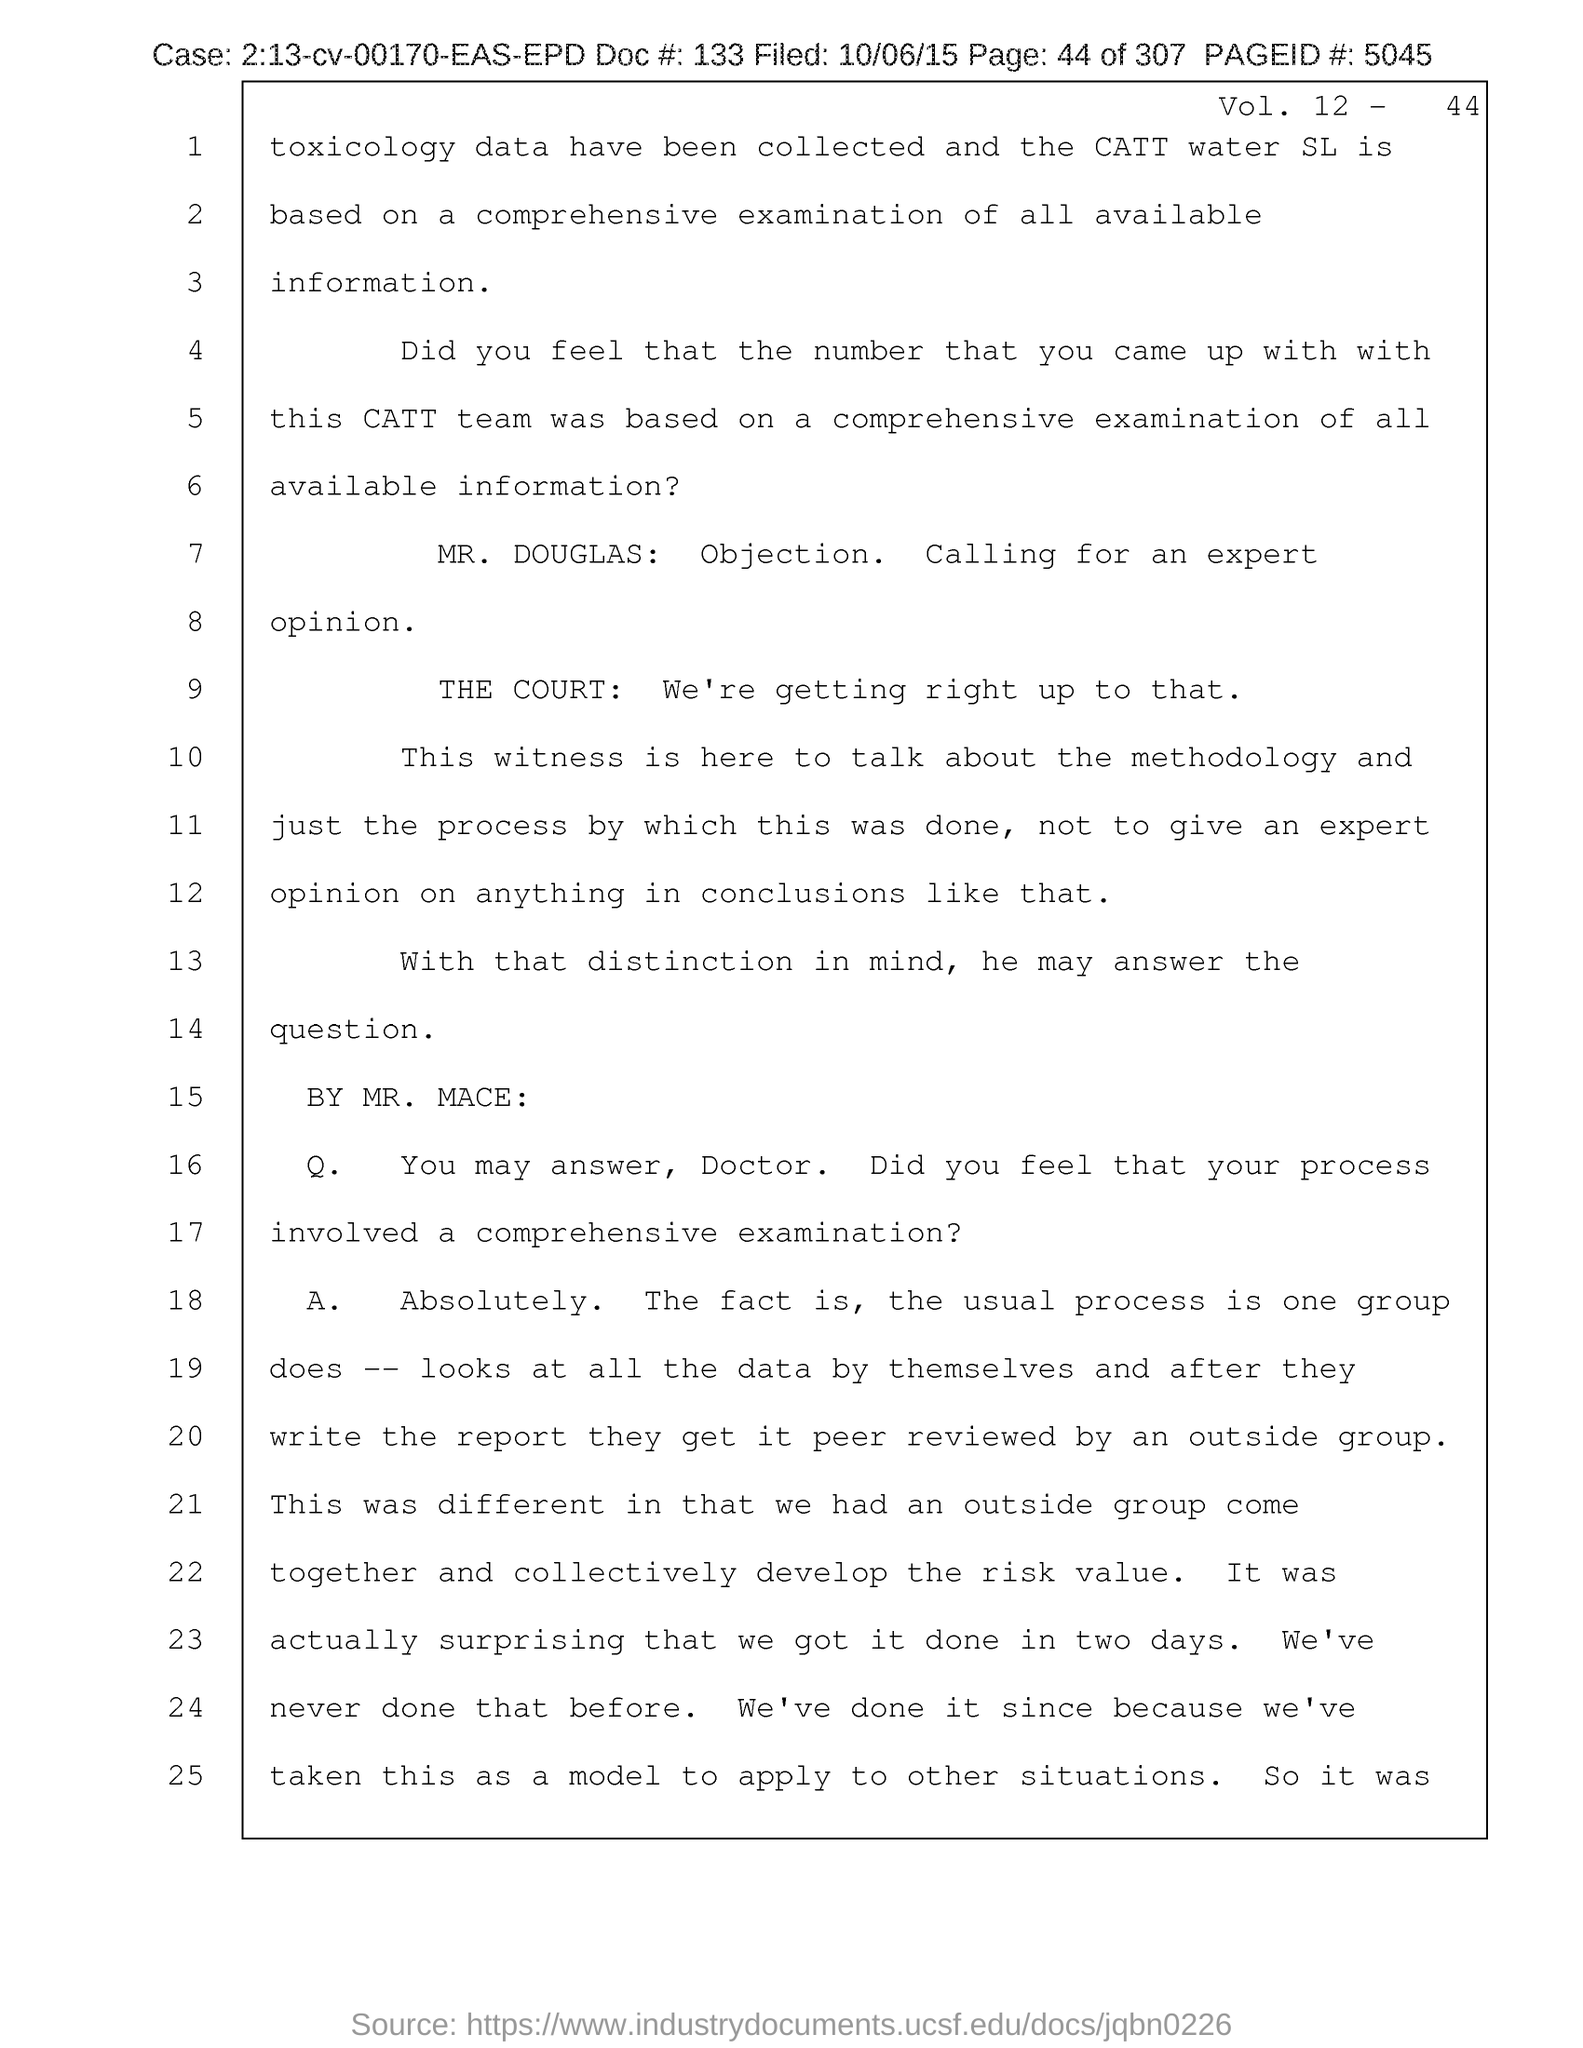Mention a couple of crucial points in this snapshot. The page number mentioned in this document is 44. The document contains a volume number listed as "Vol. 12.." and it is unclear what the specific volume number is. The filed date of the document is 10/06/15. The case number mentioned in the document is 2:13-cv-00170-EAS-EPD. The Page ID # mentioned in the document is 5045. 